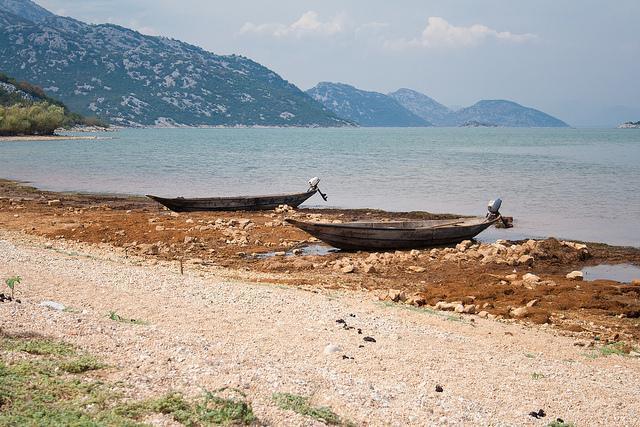How many boats are in the photo?
Give a very brief answer. 2. How many boats are about to get in the water?
Give a very brief answer. 2. How many boats can be seen?
Give a very brief answer. 2. 